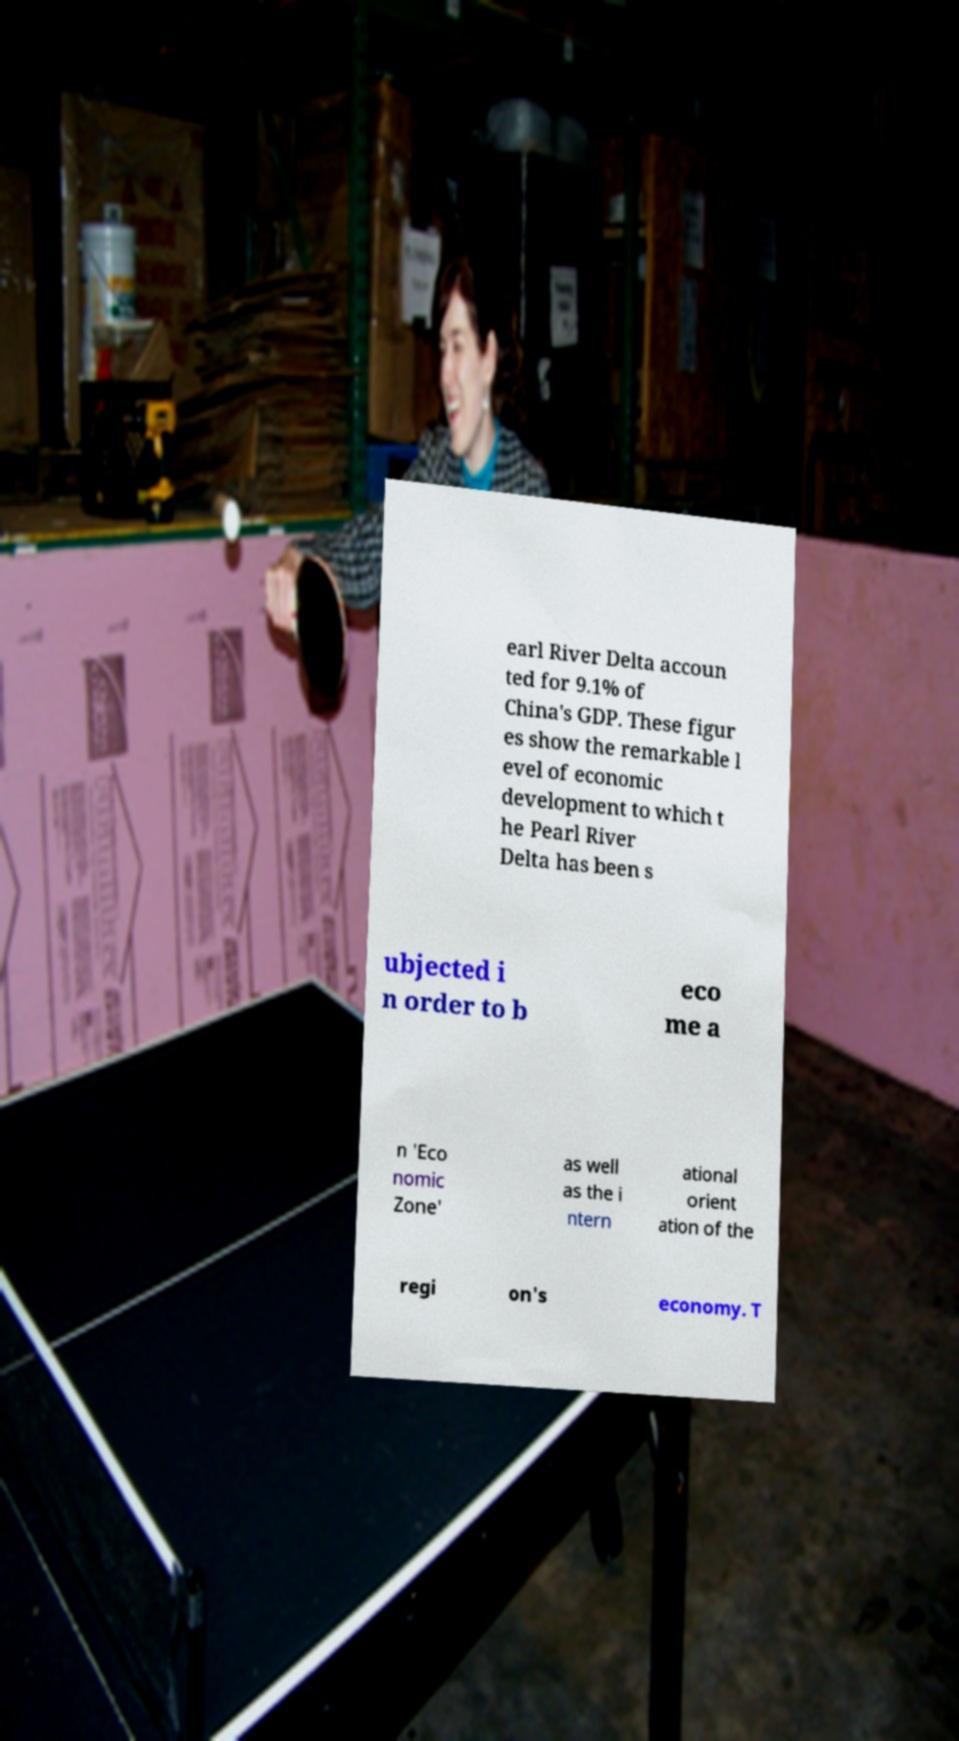Could you extract and type out the text from this image? earl River Delta accoun ted for 9.1% of China's GDP. These figur es show the remarkable l evel of economic development to which t he Pearl River Delta has been s ubjected i n order to b eco me a n 'Eco nomic Zone' as well as the i ntern ational orient ation of the regi on's economy. T 